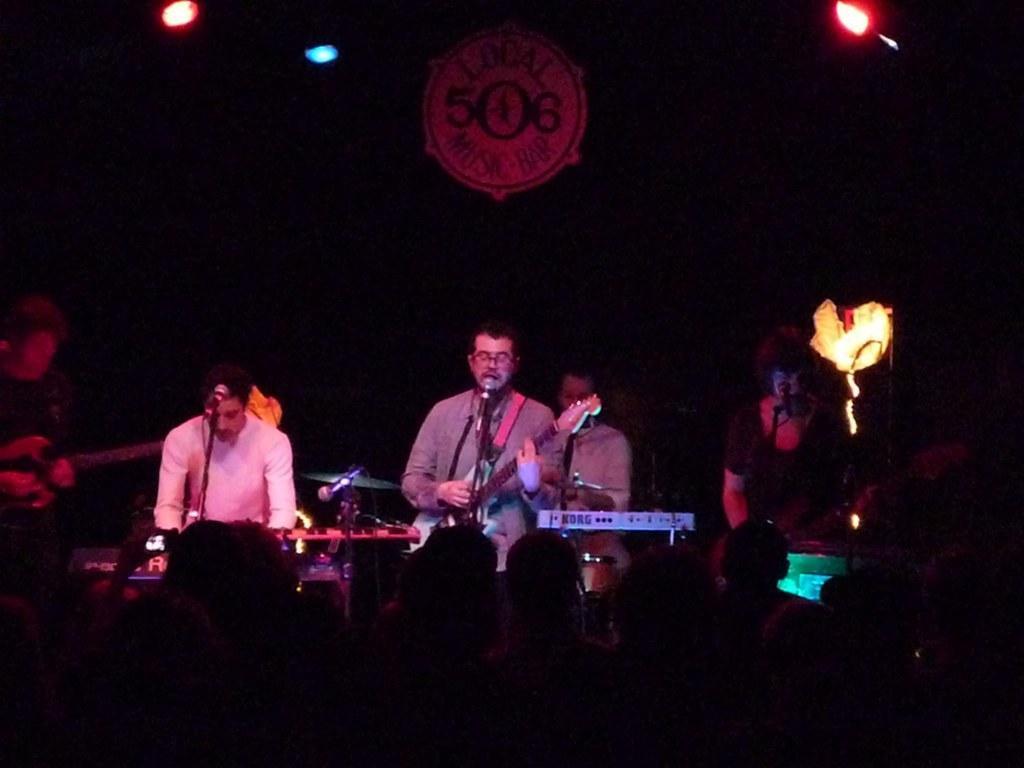Describe this image in one or two sentences. The picture is taken on the stage where there are people, on the right corner of the picture a person is standing and wearing t-shirt and in the middle of the picture the person is playing a guitar and singing in the microphone and at the right corner of the picture the person standing, beside him the person is wearing a white shirt and in front of them there is crowd and behind the center person there is a man sitting and playing the drums and behind them there is a big black curtain with text written on it. 